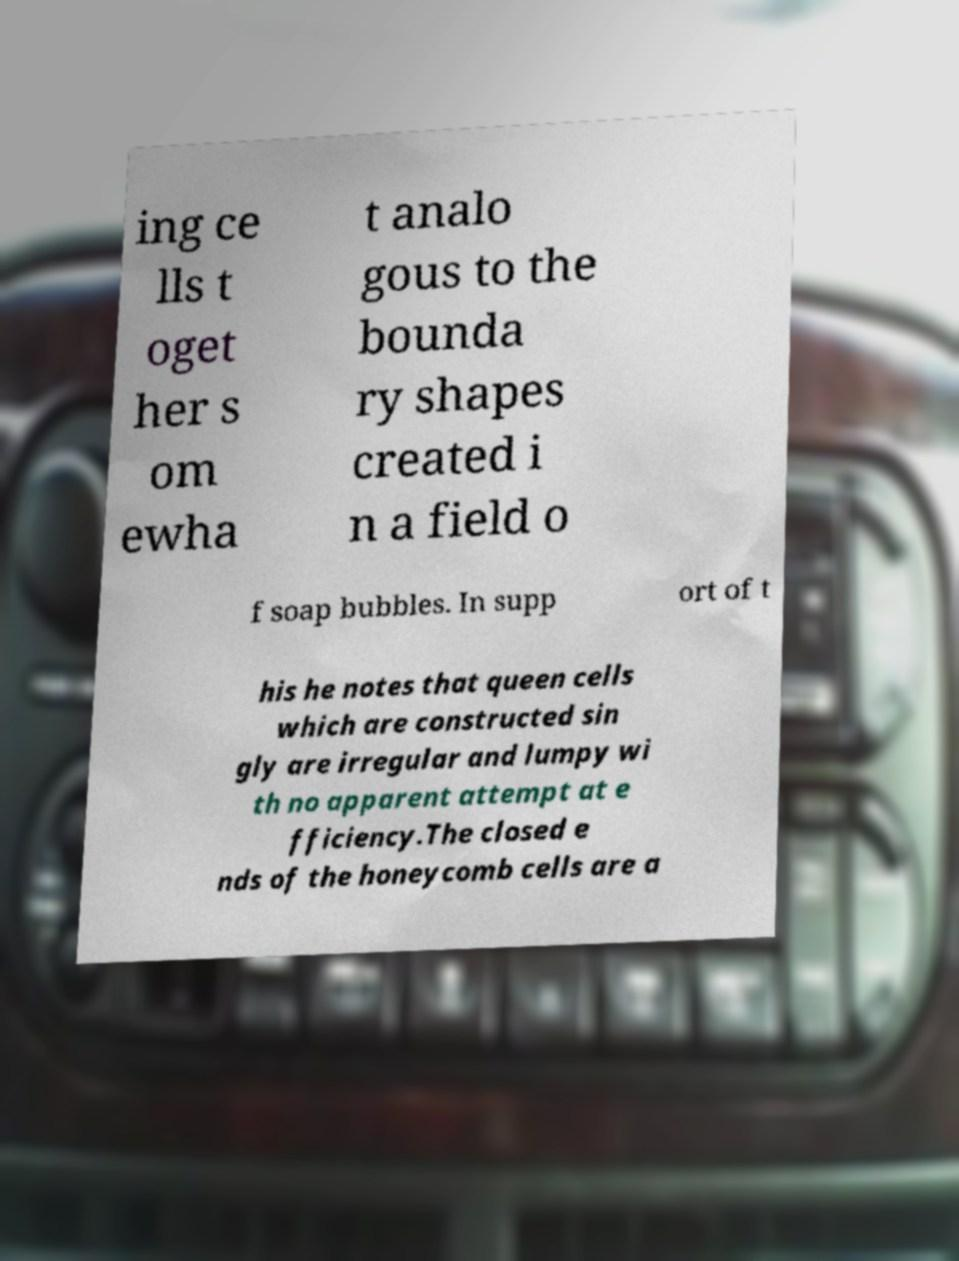Can you read and provide the text displayed in the image?This photo seems to have some interesting text. Can you extract and type it out for me? ing ce lls t oget her s om ewha t analo gous to the bounda ry shapes created i n a field o f soap bubbles. In supp ort of t his he notes that queen cells which are constructed sin gly are irregular and lumpy wi th no apparent attempt at e fficiency.The closed e nds of the honeycomb cells are a 